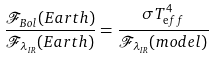Convert formula to latex. <formula><loc_0><loc_0><loc_500><loc_500>\frac { \mathcal { F } _ { B o l } ( E a r t h ) } { \mathcal { F } _ { \lambda _ { I R } } ( E a r t h ) } = \frac { \sigma T _ { \mathrm e f f } ^ { 4 } } { \mathcal { F } _ { \lambda _ { I R } } ( m o d e l ) }</formula> 